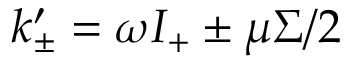<formula> <loc_0><loc_0><loc_500><loc_500>k _ { \pm } ^ { \prime } = \omega I _ { + } \pm \mu \Sigma / 2</formula> 